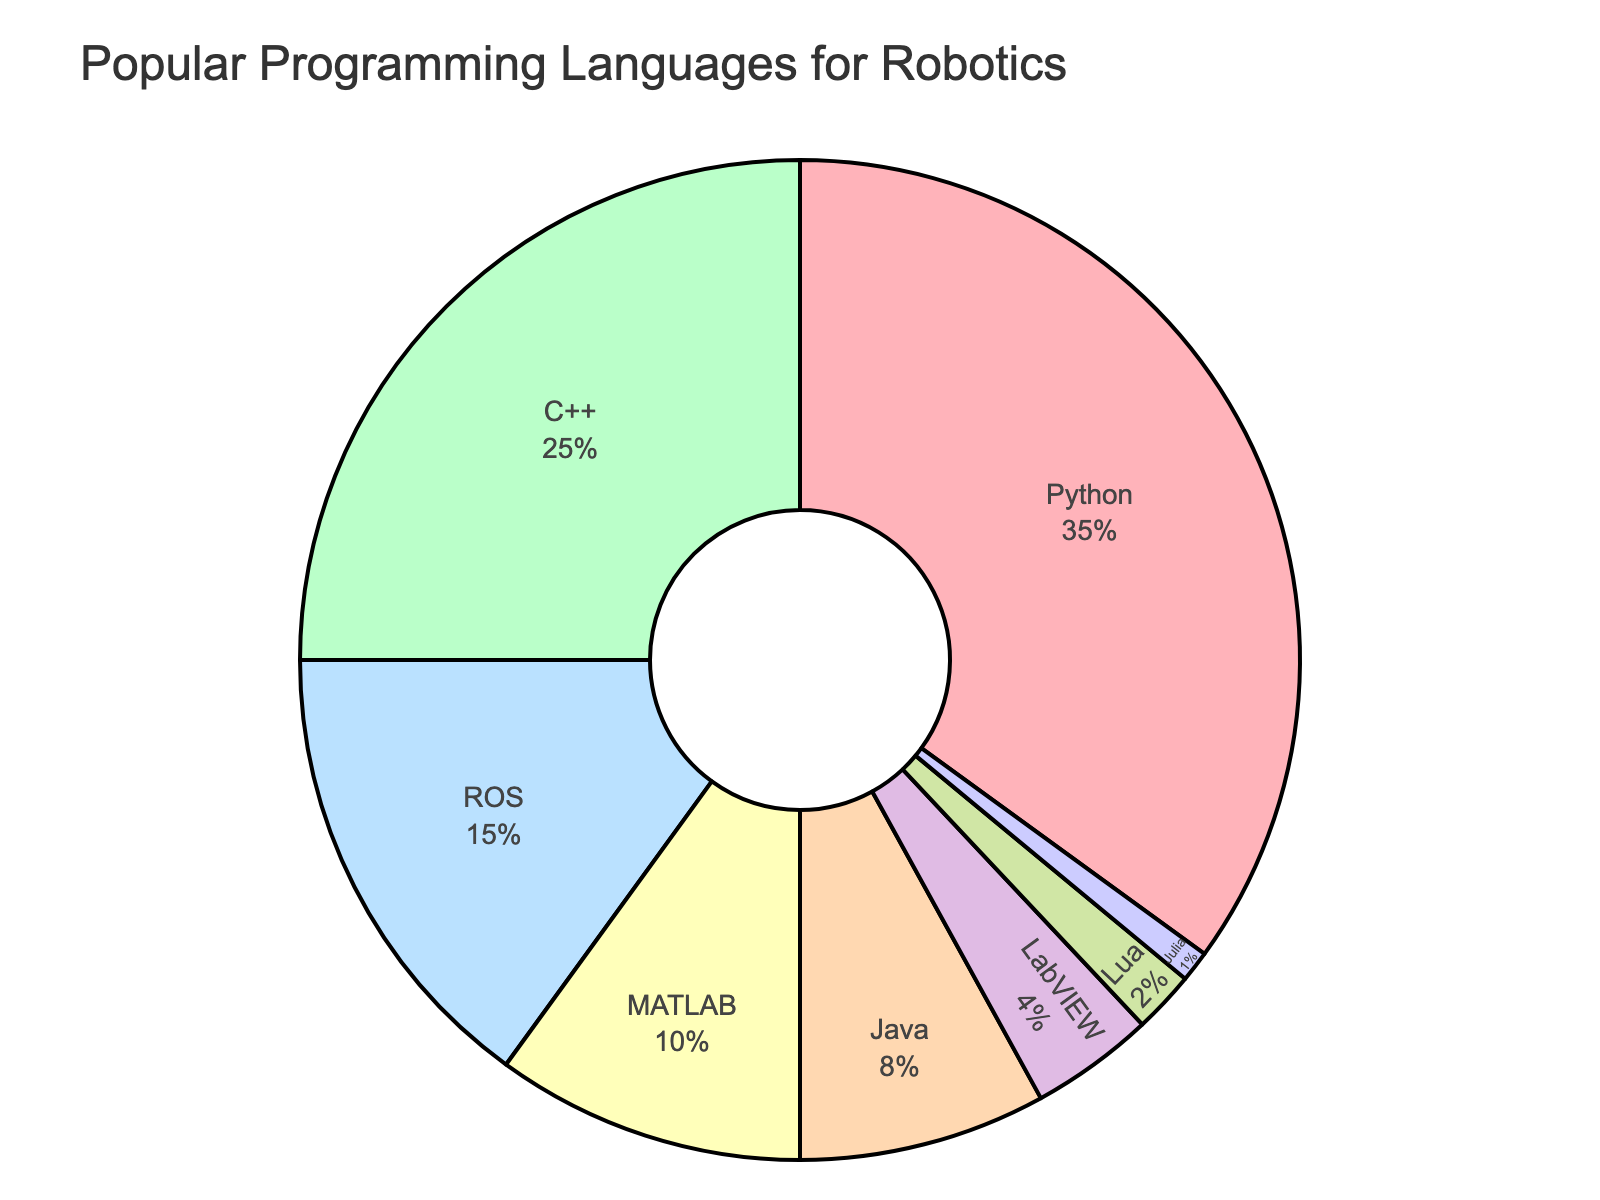Which programming language is used the most for robotics? The figure shows the percentages of different programming languages used for robotics. The largest section is labeled Python with 35%.
Answer: Python Which programming language is used the least for robotics? The figure shows the percentages of different programming languages used for robotics. The smallest section is labeled Julia with 1%.
Answer: Julia How much greater is the percentage of Python users compared to C++ users? The figure shows Python at 35% and C++ at 25%. The difference is calculated as 35% - 25%.
Answer: 10% What is the combined percentage of users who prefer Python and C++ for robotics? The figure shows Python at 35% and C++ at 25%. The combined percentage is calculated as 35% + 25%.
Answer: 60% Which language has a lower percentage, MATLAB or ROS, and by how much? The figure shows MATLAB at 10% and ROS at 15%. MATLAB has a lower percentage. The difference is calculated as 15% - 10%.
Answer: MATLAB, 5% What is the total percentage for languages other than Python and C++? The figure shows Python at 35% and C++ at 25%. The total percentage for other languages is 100% - (35% + 25%).
Answer: 40% Which language has almost double the percentage of LabVIEW? The figure shows LabVIEW at 4% and Java at 8%. Java has almost double the percentage of LabVIEW.
Answer: Java How much larger is the combined percentage of ROS and MATLAB compared to that of Java? The figure shows ROS at 15%, MATLAB at 10%, and Java at 8%. The combined percentage for ROS and MATLAB is 15% + 10% = 25%. The difference compared to Java is 25% - 8%.
Answer: 17% What percentage of users prefer languages other than the top three (Python, C++, ROS)? The figure shows Python at 35%, C++ at 25%, and ROS at 15%. The combined percentage for these three is 35% + 25% + 15% = 75%. The percentage for other languages is 100% - 75%.
Answer: 25% Which two languages together have almost the same percentage as C++ alone? The figure shows C++ at 25%. ROS is at 15% and MATLAB is at 10%. Combined, they make up 15% + 10% = 25%, which is the same as C++ alone.
Answer: ROS and MATLAB 